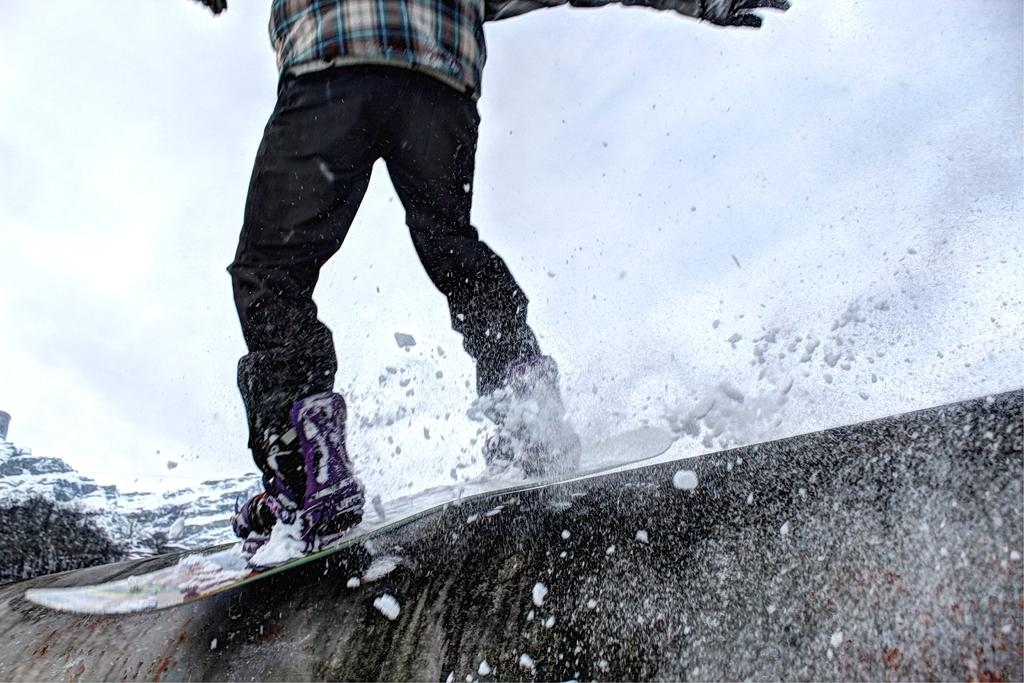What is the person in the image doing? There is a person on a surfboard in the image. What is the primary setting of the image? There is water visible in the image. What can be seen in the background of the image? The sky is visible in the background of the image. What type of kite is the person holding while surfing in the image? There is no kite present in the image; the person is only on a surfboard. Is there a bear visible in the image? No, there is no bear present in the image. 